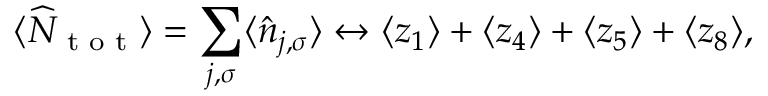Convert formula to latex. <formula><loc_0><loc_0><loc_500><loc_500>\langle \widehat { N } _ { t o t } \rangle = \sum _ { j , \sigma } \langle \hat { n } _ { { j } , \sigma } \rangle \leftrightarrow \langle z _ { 1 } \rangle + \langle z _ { 4 } \rangle + \langle z _ { 5 } \rangle + \langle z _ { 8 } \rangle ,</formula> 